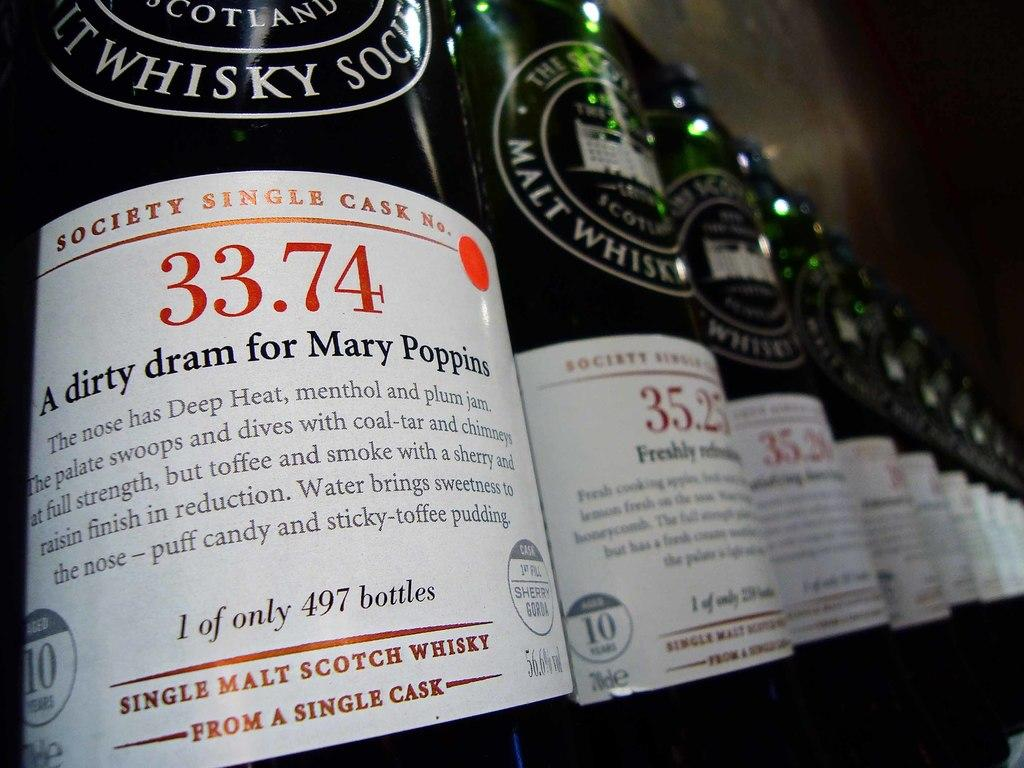Provide a one-sentence caption for the provided image. A row of Single Malt Scotch whisky bottles. 